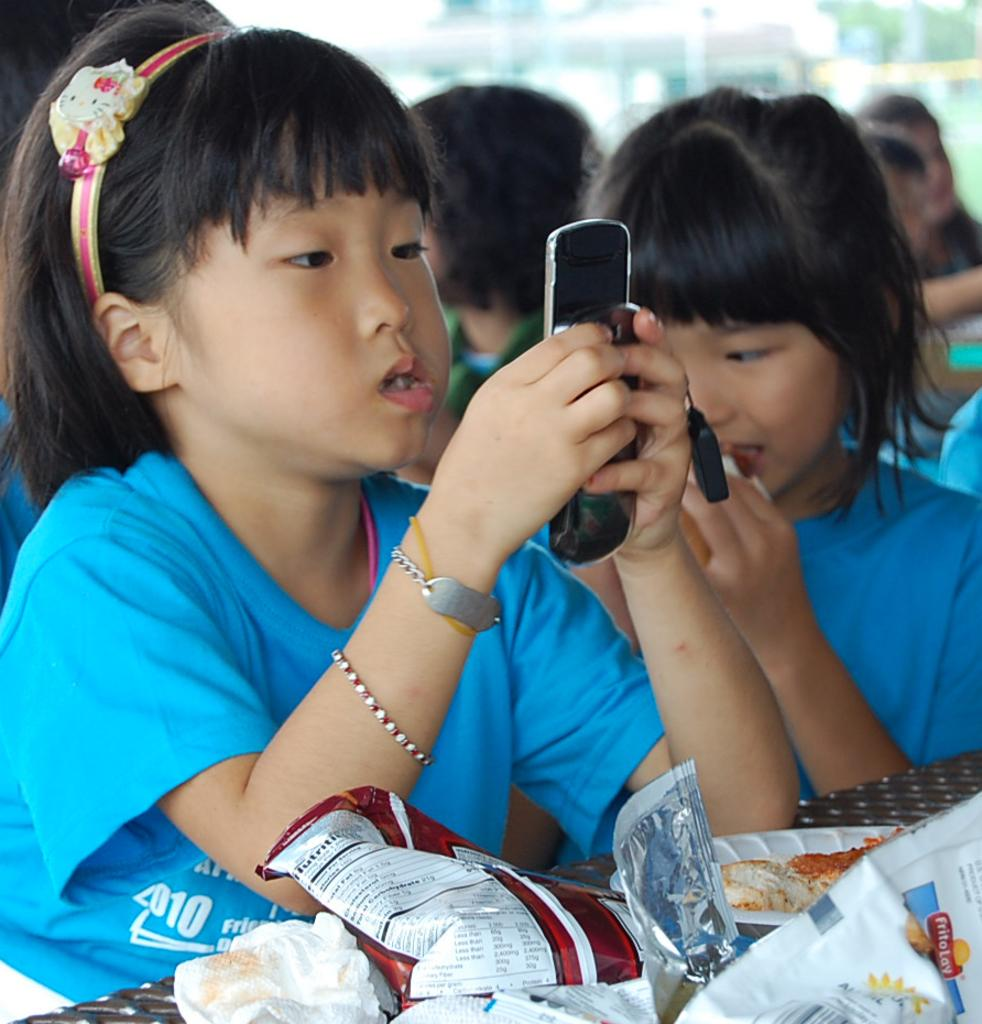What is the girl in the image doing? The girl is sitting in the image. What is the girl holding in her hand? The girl is holding a cellphone in her hand. What can be seen in the background of the image? There are people and trees in the background of the image. What type of battle is taking place in the image? There is no battle present in the image; it features a girl sitting and holding a cellphone. What type of harmony is being depicted in the image? The image does not depict any specific harmony; it simply shows a girl sitting and holding a cellphone with people and trees in the background. 